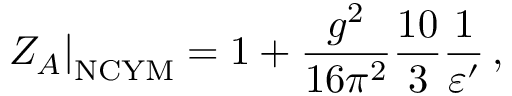Convert formula to latex. <formula><loc_0><loc_0><loc_500><loc_500>Z _ { A } \right | _ { N C Y M } = 1 + \frac { g ^ { 2 } } { 1 6 \pi ^ { 2 } } \frac { 1 0 } { 3 } \frac { 1 } { \varepsilon ^ { \prime } } \, ,</formula> 